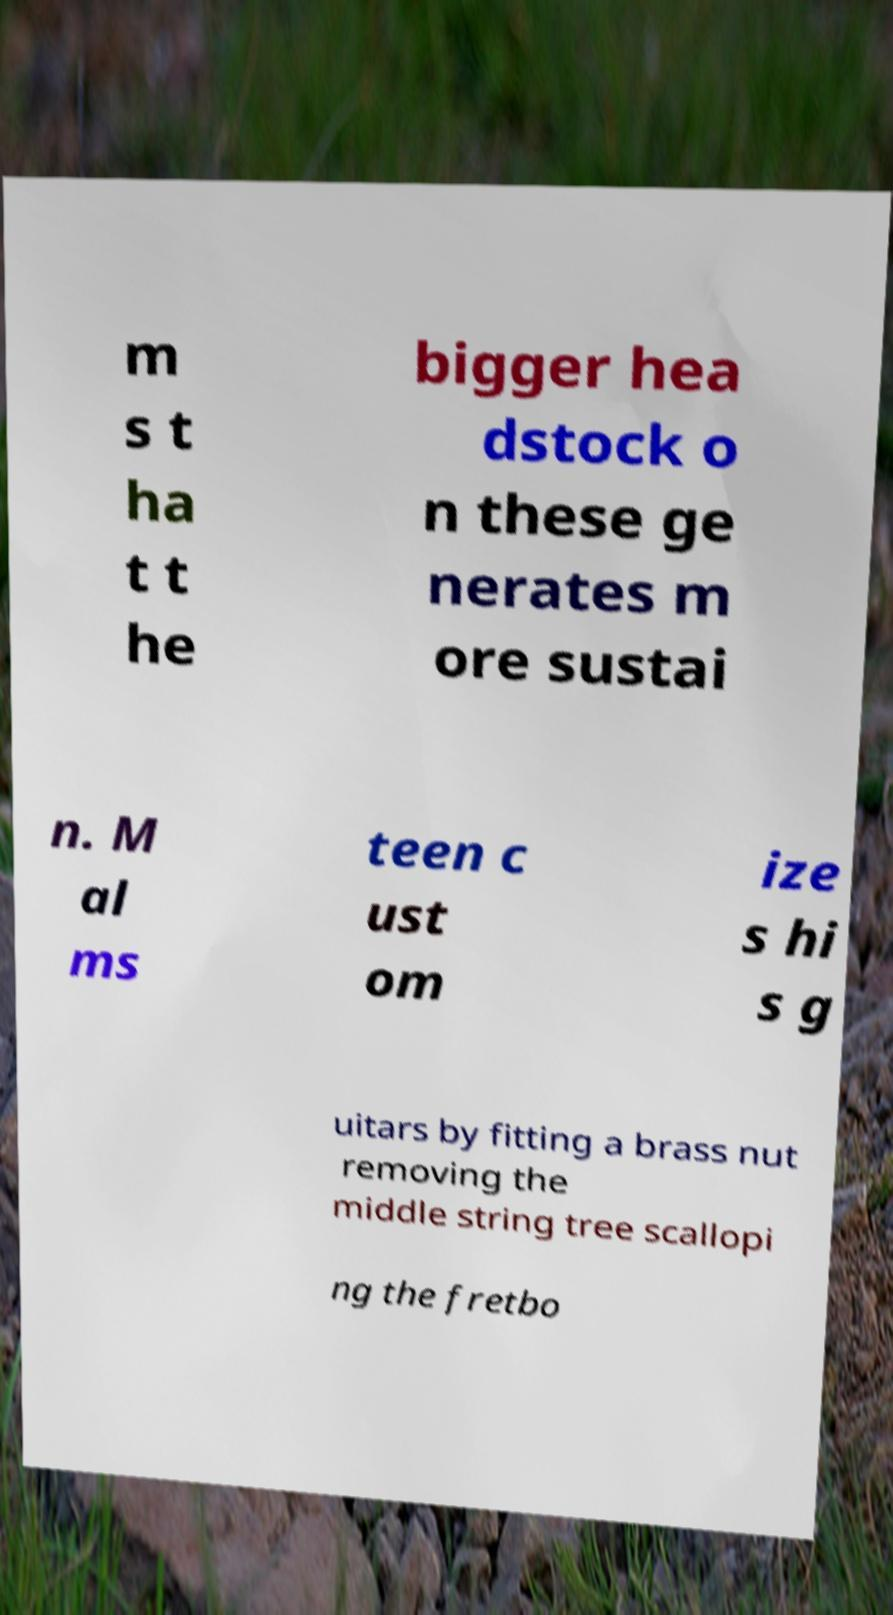Can you read and provide the text displayed in the image?This photo seems to have some interesting text. Can you extract and type it out for me? m s t ha t t he bigger hea dstock o n these ge nerates m ore sustai n. M al ms teen c ust om ize s hi s g uitars by fitting a brass nut removing the middle string tree scallopi ng the fretbo 